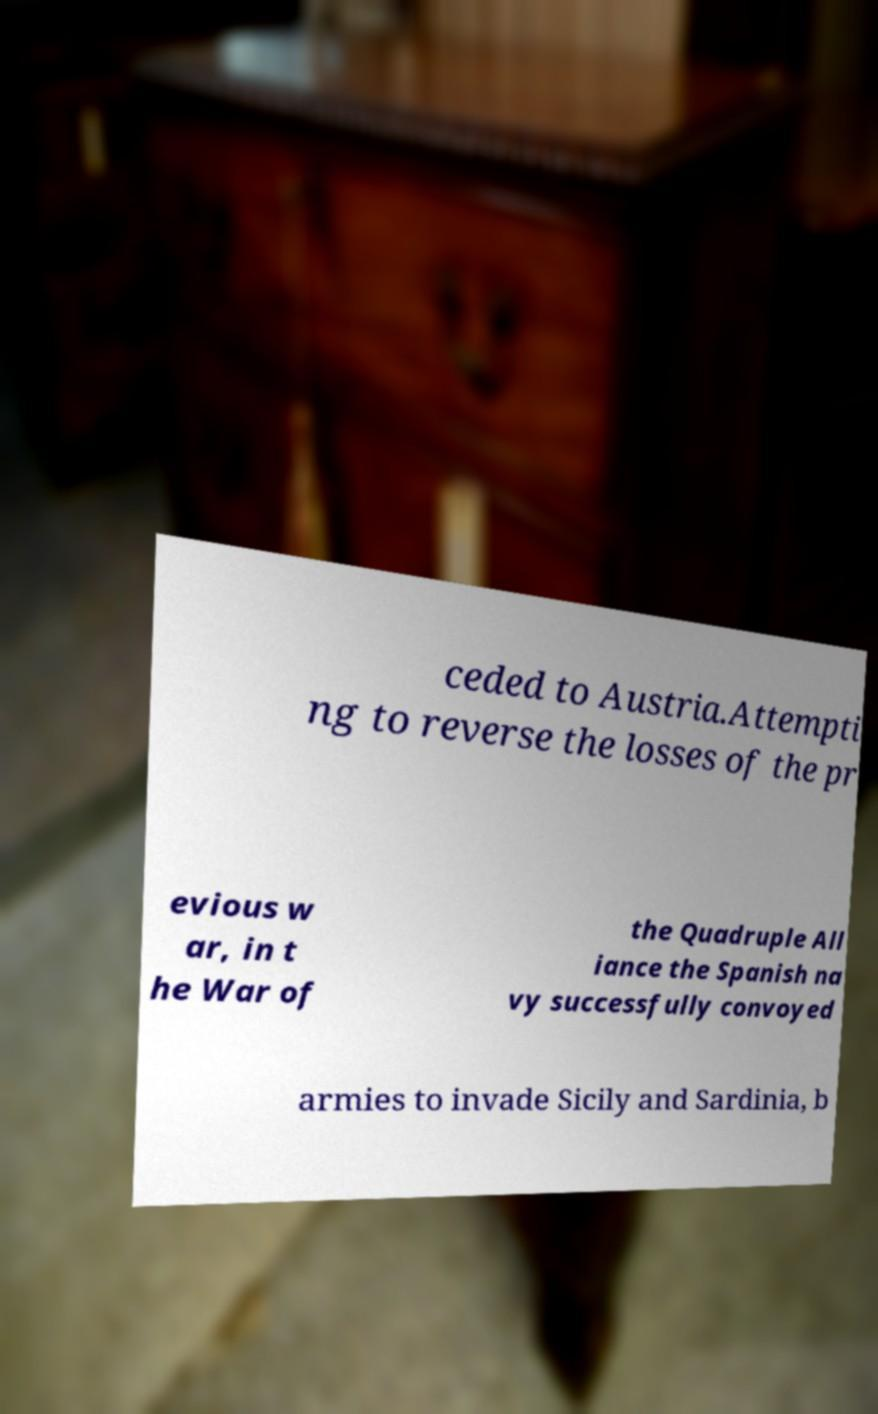Please read and relay the text visible in this image. What does it say? ceded to Austria.Attempti ng to reverse the losses of the pr evious w ar, in t he War of the Quadruple All iance the Spanish na vy successfully convoyed armies to invade Sicily and Sardinia, b 